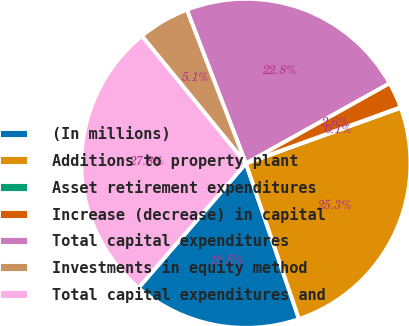<chart> <loc_0><loc_0><loc_500><loc_500><pie_chart><fcel>(In millions)<fcel>Additions to property plant<fcel>Asset retirement expenditures<fcel>Increase (decrease) in capital<fcel>Total capital expenditures<fcel>Investments in equity method<fcel>Total capital expenditures and<nl><fcel>16.55%<fcel>25.26%<fcel>0.05%<fcel>2.56%<fcel>22.75%<fcel>5.06%<fcel>27.77%<nl></chart> 